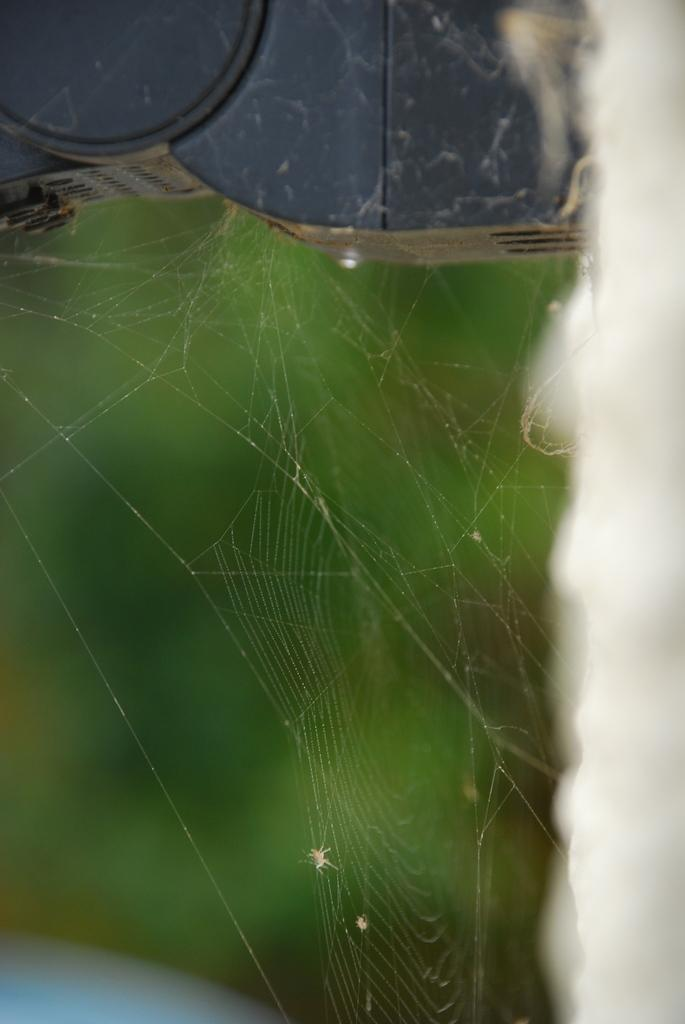What is the main subject of the image? The main subject of the image is a spider web. What color is the background of the image? The background of the image is green. Where is the cushion located in the image? There is no cushion present in the image. What type of marble can be seen in the image? There is no marble present in the image. 